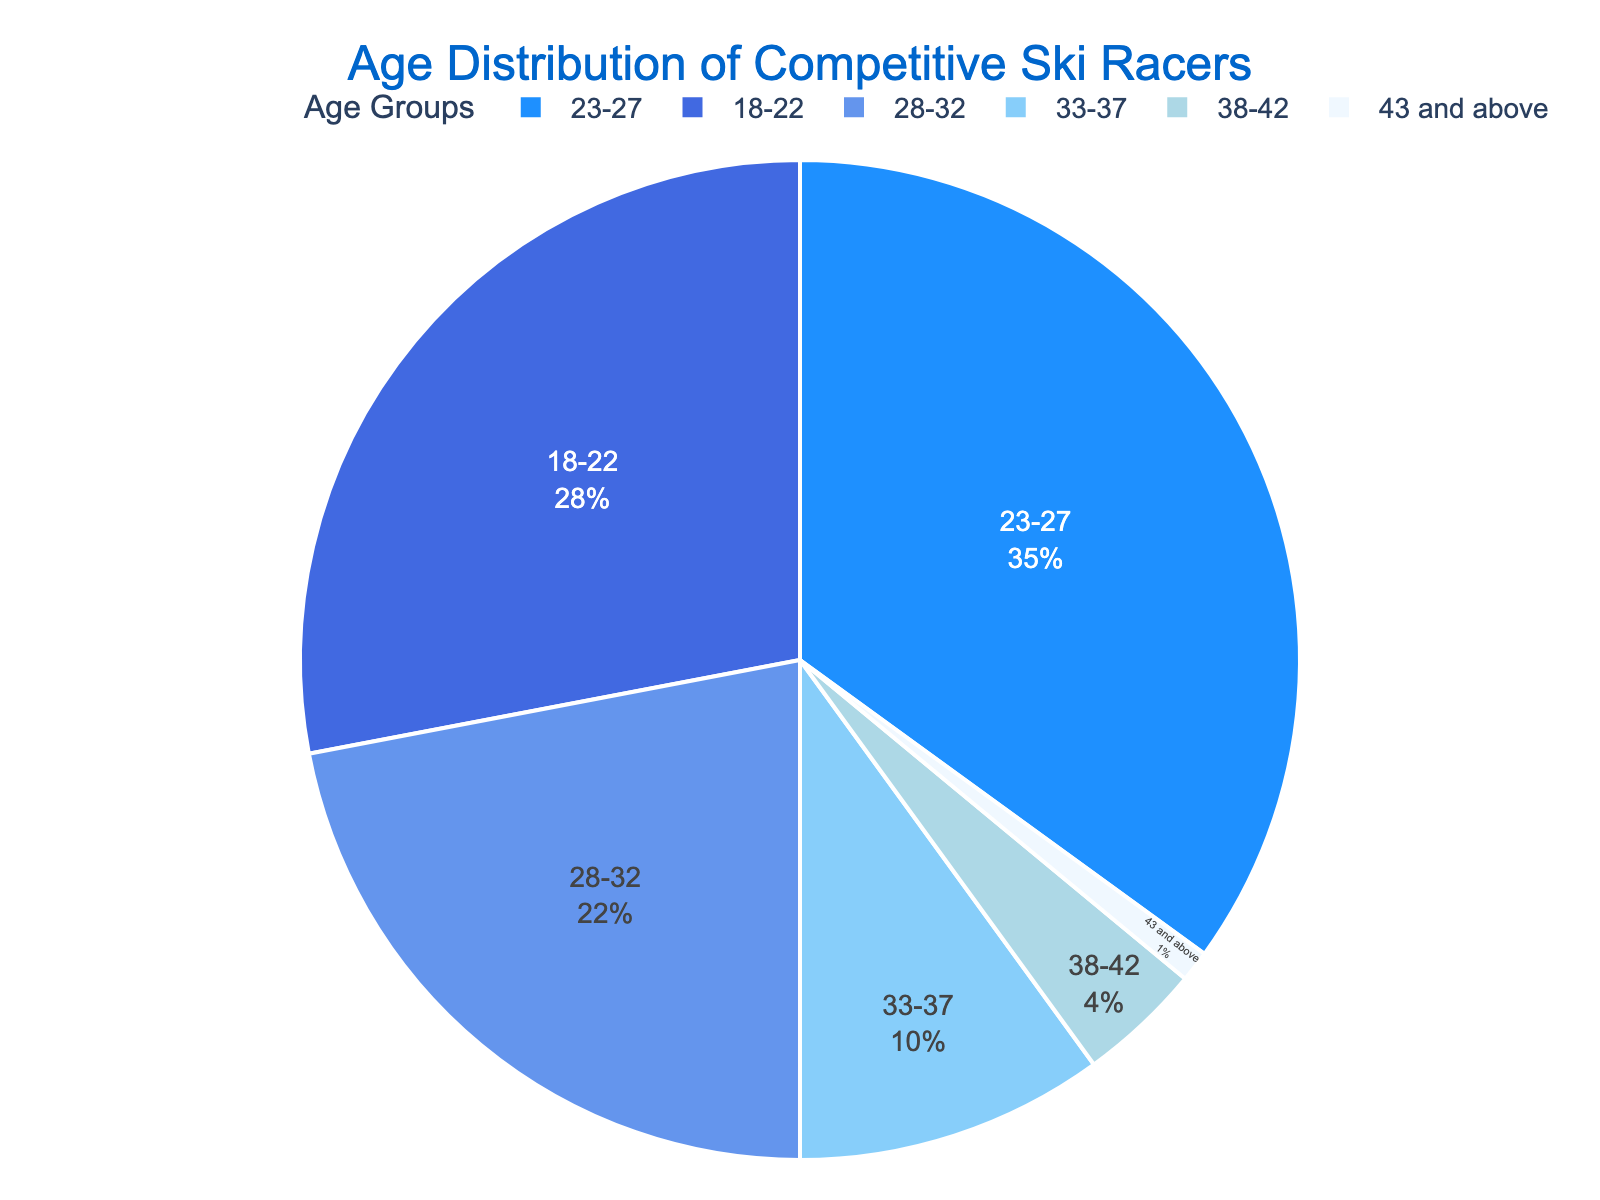What's the total percentage of ski racers aged 37 and below? The age groups 18-22, 23-27, and 28-32 fall within this range. Sum their percentages: 28% + 35% + 22% + 10% = 95%
Answer: 95% Which age group has the highest representation? By examining the pie chart, it shows that the age group 23-27 has the highest percentage (35%).
Answer: 23-27 How many percentage points is the group 23-27 greater than the group 28-32? Subtract the percentage of the 28-32 group (22%) from the 23-27 group (35%): 35% - 22% = 13%
Answer: 13% Is the percentage of ski racers aged 33 and above greater or less than 15%? Adding the percentages of the 33-37, 38-42, and 43 and above groups: 10% + 4% + 1% = 15%. The percentage is equal to 15%.
Answer: Equal to 15% What is the difference in representation between the oldest and youngest age groups? Subtract the percentage of the 43 and above group (1%) from the 18-22 group (28%): 28% - 1% = 27%
Answer: 27% Which age group is represented by a light blue color? By visual inspection of the pie chart, the light blue color corresponds to the age group 33-37.
Answer: 33-37 What percentage of ski racers are aged between 18 and 27? Sum the percentages of the 18-22 and 23-27 age groups: 28% + 35% = 63%
Answer: 63% Is the combined percentage of the two smallest age groups larger than the percentage of the 28-32 group? The two smallest age groups are 38-42 (4%) and 43 and above (1%). Their combined percentage is 4% + 1% = 5%. This is smaller than the 28-32 group's 22%.
Answer: No What's the average percentage of the age groups from 28 to 42? Sum the percentages of the age groups 28-32, 33-37, and 38-42: 22% + 10% + 4% = 36%. Divide by 3 to get the average: 36% / 3 = 12%
Answer: 12% Between which two age groups is there the largest difference in their representation, and what is this difference? The largest difference is between the age groups 23-27 (35%) and 43 and above (1%). Subtract 1% from 35% to get the difference: 35% - 1% = 34%
Answer: 23-27 and 43 and above, 34% 